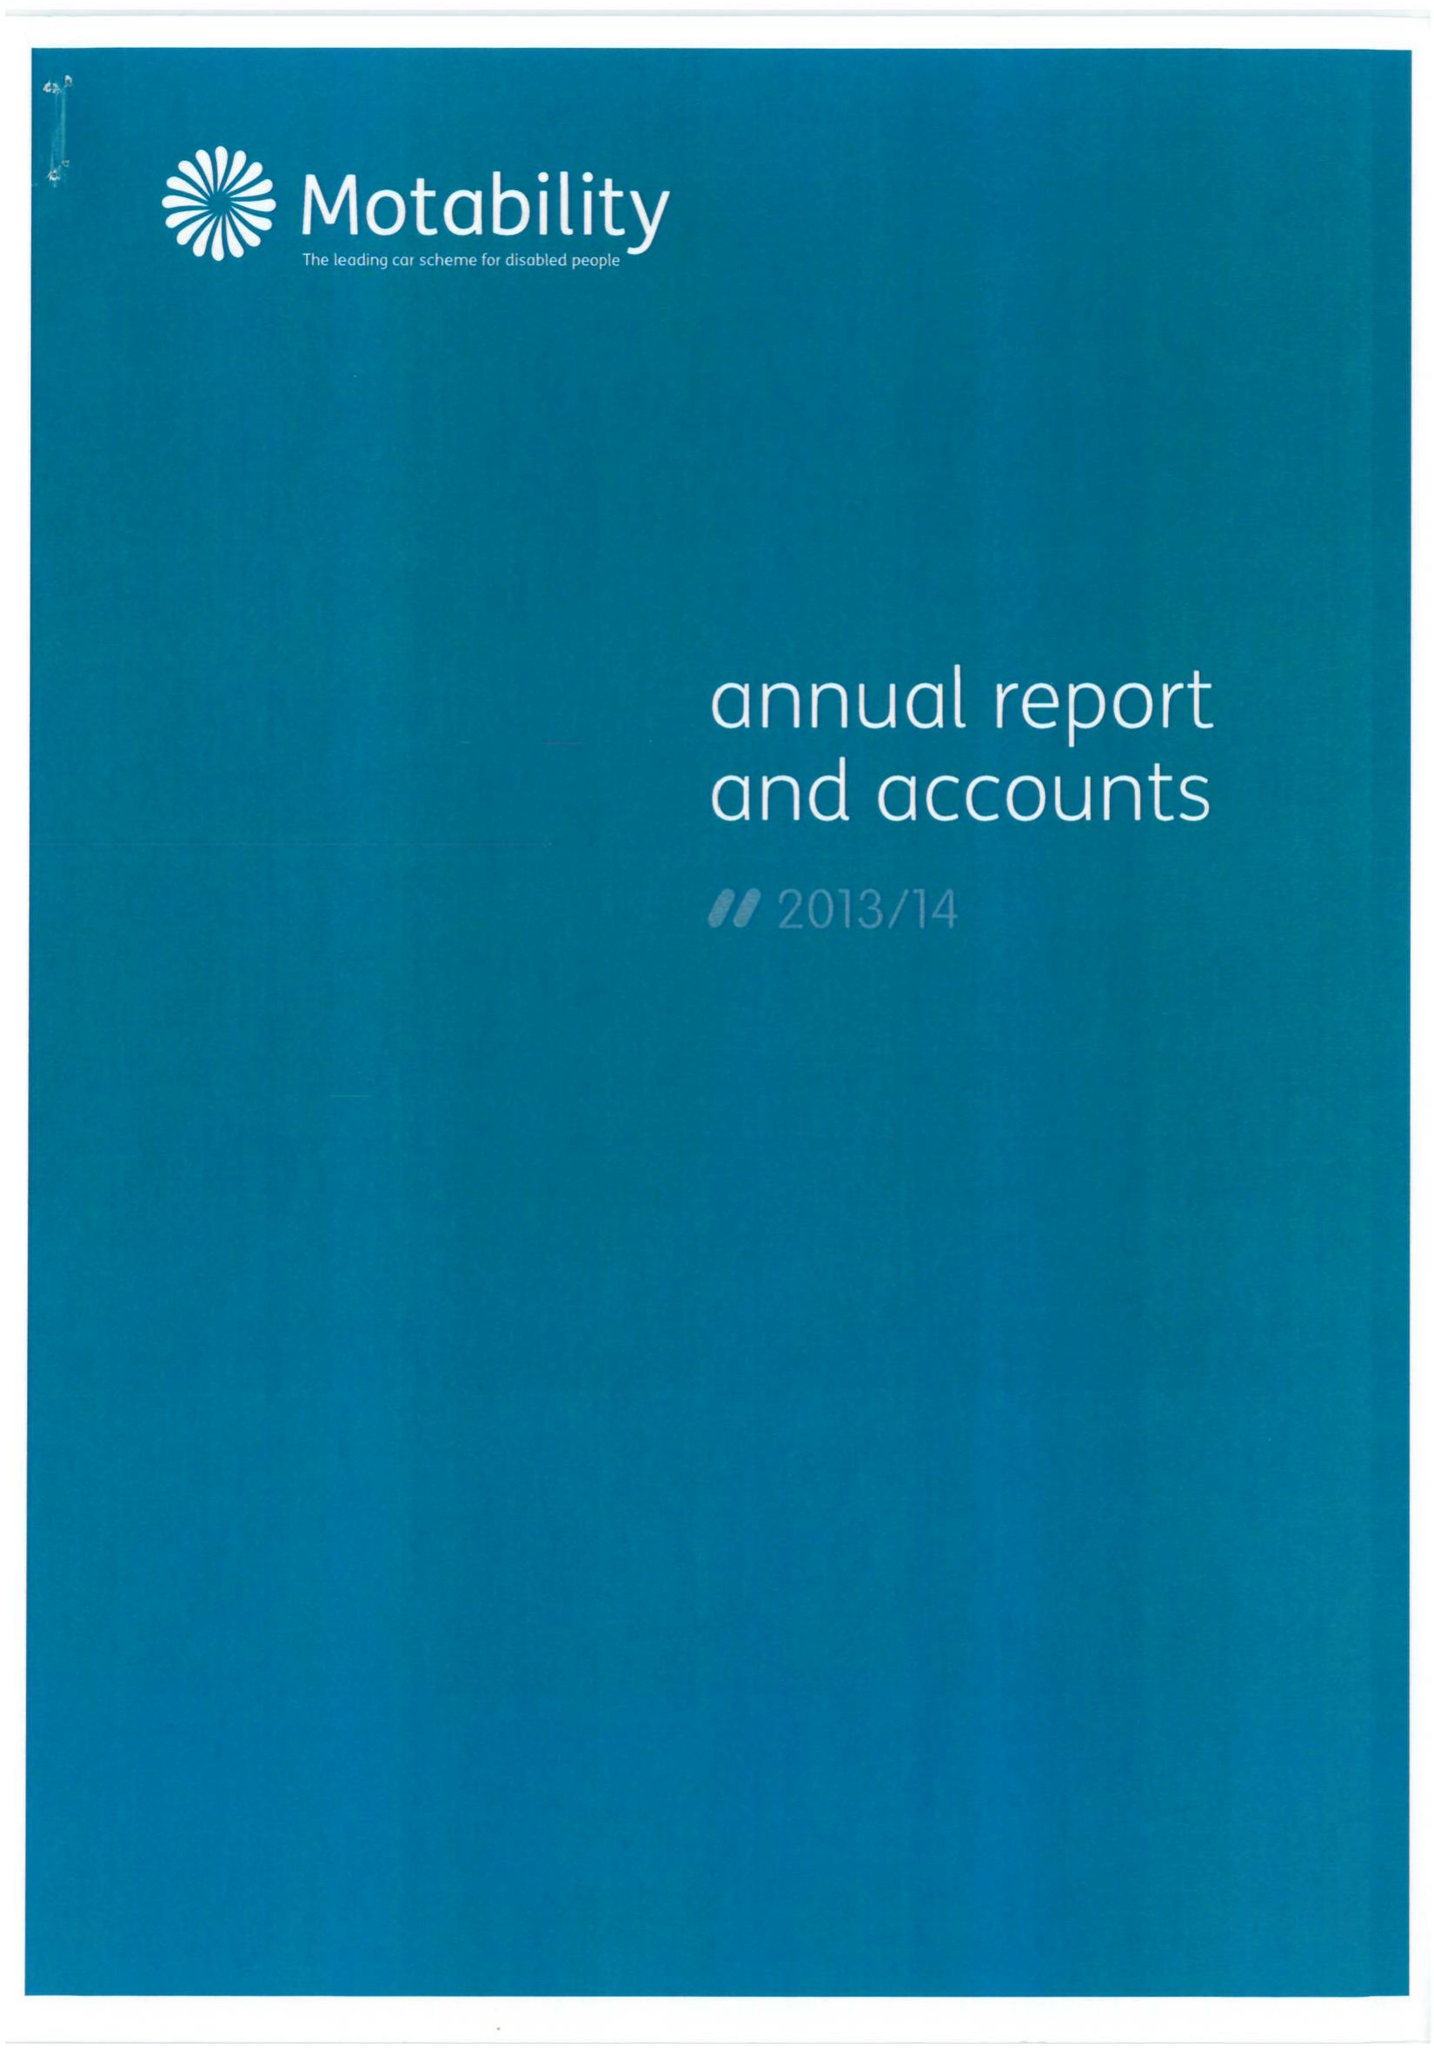What is the value for the address__street_line?
Answer the question using a single word or phrase. ROYDON ROAD 